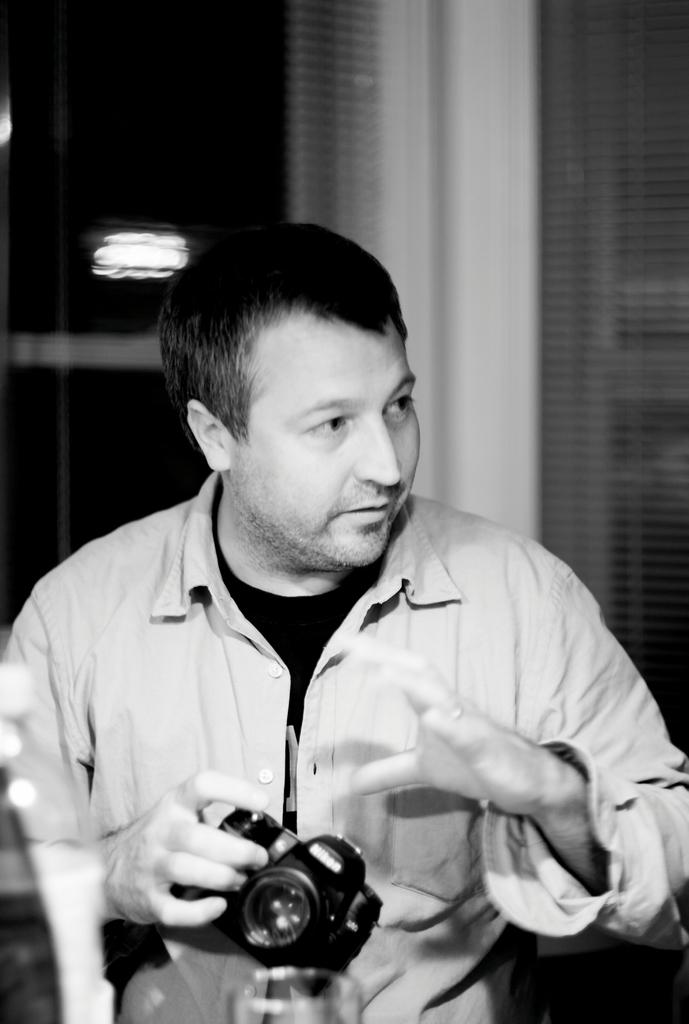What is the main subject of the image? There is a man standing in the middle of the image. What is the man holding in the image? The man is holding a camera. Where can a water bottle be found in the image? There is a water bottle in the bottom left side of the image. What can be seen in the top left side of the image? There is a light in the top left side of the image. What type of linen is draped over the man's skirt in the image? There is no linen or skirt present in the image; the man is wearing regular clothing and holding a camera. 